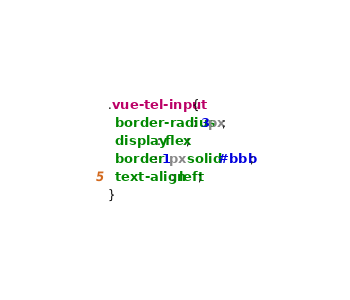<code> <loc_0><loc_0><loc_500><loc_500><_CSS_>.vue-tel-input {
  border-radius: 3px;
  display: flex;
  border: 1px solid #bbb;
  text-align: left;
}</code> 